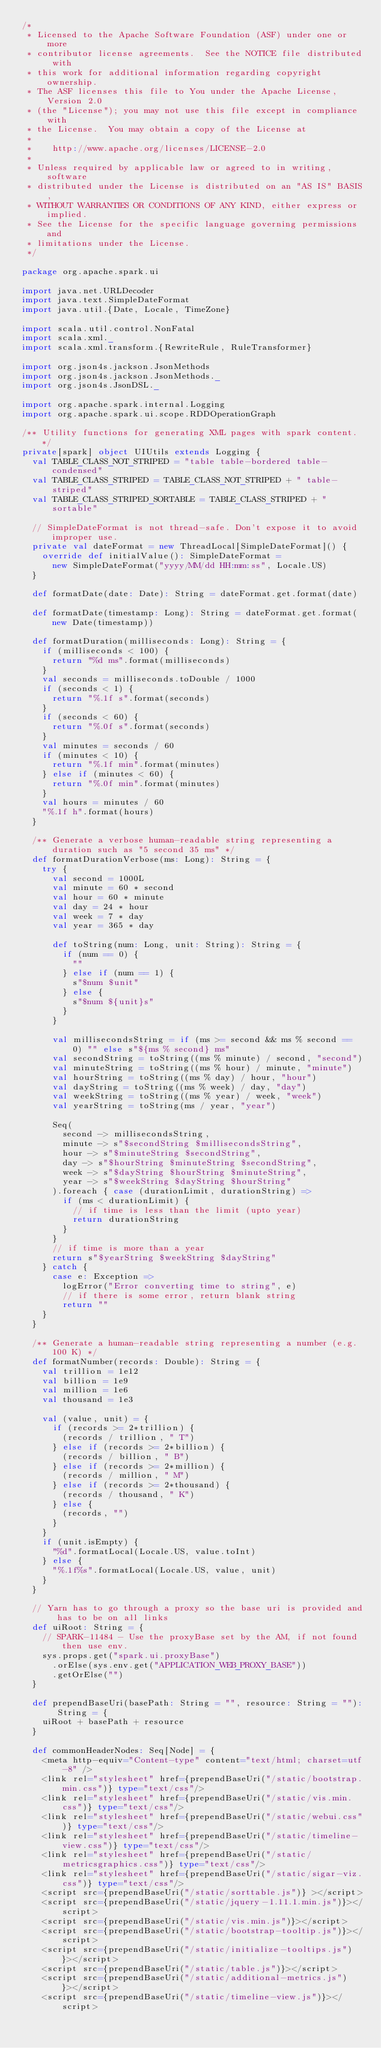Convert code to text. <code><loc_0><loc_0><loc_500><loc_500><_Scala_>/*
 * Licensed to the Apache Software Foundation (ASF) under one or more
 * contributor license agreements.  See the NOTICE file distributed with
 * this work for additional information regarding copyright ownership.
 * The ASF licenses this file to You under the Apache License, Version 2.0
 * (the "License"); you may not use this file except in compliance with
 * the License.  You may obtain a copy of the License at
 *
 *    http://www.apache.org/licenses/LICENSE-2.0
 *
 * Unless required by applicable law or agreed to in writing, software
 * distributed under the License is distributed on an "AS IS" BASIS,
 * WITHOUT WARRANTIES OR CONDITIONS OF ANY KIND, either express or implied.
 * See the License for the specific language governing permissions and
 * limitations under the License.
 */

package org.apache.spark.ui

import java.net.URLDecoder
import java.text.SimpleDateFormat
import java.util.{Date, Locale, TimeZone}

import scala.util.control.NonFatal
import scala.xml._
import scala.xml.transform.{RewriteRule, RuleTransformer}

import org.json4s.jackson.JsonMethods
import org.json4s.jackson.JsonMethods._
import org.json4s.JsonDSL._

import org.apache.spark.internal.Logging
import org.apache.spark.ui.scope.RDDOperationGraph

/** Utility functions for generating XML pages with spark content. */
private[spark] object UIUtils extends Logging {
  val TABLE_CLASS_NOT_STRIPED = "table table-bordered table-condensed"
  val TABLE_CLASS_STRIPED = TABLE_CLASS_NOT_STRIPED + " table-striped"
  val TABLE_CLASS_STRIPED_SORTABLE = TABLE_CLASS_STRIPED + " sortable"

  // SimpleDateFormat is not thread-safe. Don't expose it to avoid improper use.
  private val dateFormat = new ThreadLocal[SimpleDateFormat]() {
    override def initialValue(): SimpleDateFormat =
      new SimpleDateFormat("yyyy/MM/dd HH:mm:ss", Locale.US)
  }

  def formatDate(date: Date): String = dateFormat.get.format(date)

  def formatDate(timestamp: Long): String = dateFormat.get.format(new Date(timestamp))

  def formatDuration(milliseconds: Long): String = {
    if (milliseconds < 100) {
      return "%d ms".format(milliseconds)
    }
    val seconds = milliseconds.toDouble / 1000
    if (seconds < 1) {
      return "%.1f s".format(seconds)
    }
    if (seconds < 60) {
      return "%.0f s".format(seconds)
    }
    val minutes = seconds / 60
    if (minutes < 10) {
      return "%.1f min".format(minutes)
    } else if (minutes < 60) {
      return "%.0f min".format(minutes)
    }
    val hours = minutes / 60
    "%.1f h".format(hours)
  }

  /** Generate a verbose human-readable string representing a duration such as "5 second 35 ms" */
  def formatDurationVerbose(ms: Long): String = {
    try {
      val second = 1000L
      val minute = 60 * second
      val hour = 60 * minute
      val day = 24 * hour
      val week = 7 * day
      val year = 365 * day

      def toString(num: Long, unit: String): String = {
        if (num == 0) {
          ""
        } else if (num == 1) {
          s"$num $unit"
        } else {
          s"$num ${unit}s"
        }
      }

      val millisecondsString = if (ms >= second && ms % second == 0) "" else s"${ms % second} ms"
      val secondString = toString((ms % minute) / second, "second")
      val minuteString = toString((ms % hour) / minute, "minute")
      val hourString = toString((ms % day) / hour, "hour")
      val dayString = toString((ms % week) / day, "day")
      val weekString = toString((ms % year) / week, "week")
      val yearString = toString(ms / year, "year")

      Seq(
        second -> millisecondsString,
        minute -> s"$secondString $millisecondsString",
        hour -> s"$minuteString $secondString",
        day -> s"$hourString $minuteString $secondString",
        week -> s"$dayString $hourString $minuteString",
        year -> s"$weekString $dayString $hourString"
      ).foreach { case (durationLimit, durationString) =>
        if (ms < durationLimit) {
          // if time is less than the limit (upto year)
          return durationString
        }
      }
      // if time is more than a year
      return s"$yearString $weekString $dayString"
    } catch {
      case e: Exception =>
        logError("Error converting time to string", e)
        // if there is some error, return blank string
        return ""
    }
  }

  /** Generate a human-readable string representing a number (e.g. 100 K) */
  def formatNumber(records: Double): String = {
    val trillion = 1e12
    val billion = 1e9
    val million = 1e6
    val thousand = 1e3

    val (value, unit) = {
      if (records >= 2*trillion) {
        (records / trillion, " T")
      } else if (records >= 2*billion) {
        (records / billion, " B")
      } else if (records >= 2*million) {
        (records / million, " M")
      } else if (records >= 2*thousand) {
        (records / thousand, " K")
      } else {
        (records, "")
      }
    }
    if (unit.isEmpty) {
      "%d".formatLocal(Locale.US, value.toInt)
    } else {
      "%.1f%s".formatLocal(Locale.US, value, unit)
    }
  }

  // Yarn has to go through a proxy so the base uri is provided and has to be on all links
  def uiRoot: String = {
    // SPARK-11484 - Use the proxyBase set by the AM, if not found then use env.
    sys.props.get("spark.ui.proxyBase")
      .orElse(sys.env.get("APPLICATION_WEB_PROXY_BASE"))
      .getOrElse("")
  }

  def prependBaseUri(basePath: String = "", resource: String = ""): String = {
    uiRoot + basePath + resource
  }

  def commonHeaderNodes: Seq[Node] = {
    <meta http-equiv="Content-type" content="text/html; charset=utf-8" />
    <link rel="stylesheet" href={prependBaseUri("/static/bootstrap.min.css")} type="text/css"/>
    <link rel="stylesheet" href={prependBaseUri("/static/vis.min.css")} type="text/css"/>
    <link rel="stylesheet" href={prependBaseUri("/static/webui.css")} type="text/css"/>
    <link rel="stylesheet" href={prependBaseUri("/static/timeline-view.css")} type="text/css"/>
    <link rel="stylesheet" href={prependBaseUri("/static/metricsgraphics.css")} type="text/css"/>
    <link rel="stylesheet" href={prependBaseUri("/static/sigar-viz.css")} type="text/css"/>
    <script src={prependBaseUri("/static/sorttable.js")} ></script>
    <script src={prependBaseUri("/static/jquery-1.11.1.min.js")}></script>
    <script src={prependBaseUri("/static/vis.min.js")}></script>
    <script src={prependBaseUri("/static/bootstrap-tooltip.js")}></script>
    <script src={prependBaseUri("/static/initialize-tooltips.js")}></script>
    <script src={prependBaseUri("/static/table.js")}></script>
    <script src={prependBaseUri("/static/additional-metrics.js")}></script>
    <script src={prependBaseUri("/static/timeline-view.js")}></script></code> 